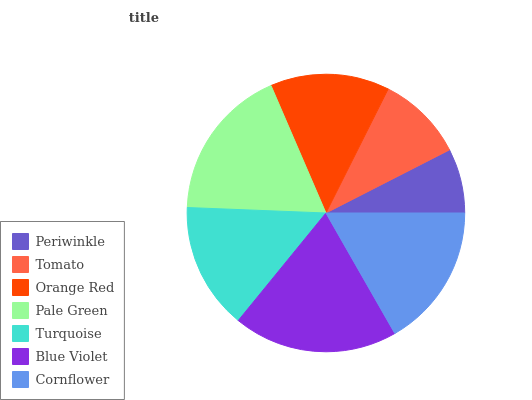Is Periwinkle the minimum?
Answer yes or no. Yes. Is Blue Violet the maximum?
Answer yes or no. Yes. Is Tomato the minimum?
Answer yes or no. No. Is Tomato the maximum?
Answer yes or no. No. Is Tomato greater than Periwinkle?
Answer yes or no. Yes. Is Periwinkle less than Tomato?
Answer yes or no. Yes. Is Periwinkle greater than Tomato?
Answer yes or no. No. Is Tomato less than Periwinkle?
Answer yes or no. No. Is Turquoise the high median?
Answer yes or no. Yes. Is Turquoise the low median?
Answer yes or no. Yes. Is Periwinkle the high median?
Answer yes or no. No. Is Tomato the low median?
Answer yes or no. No. 